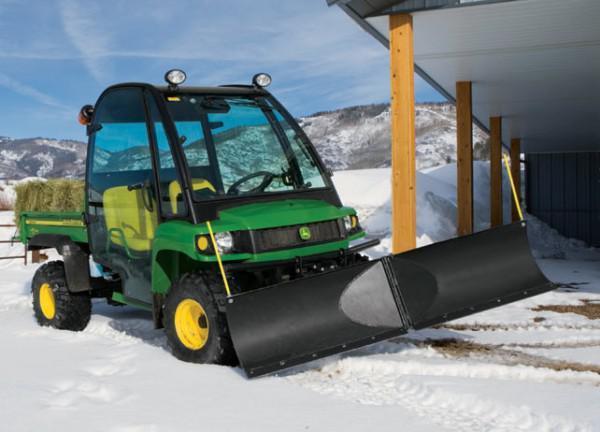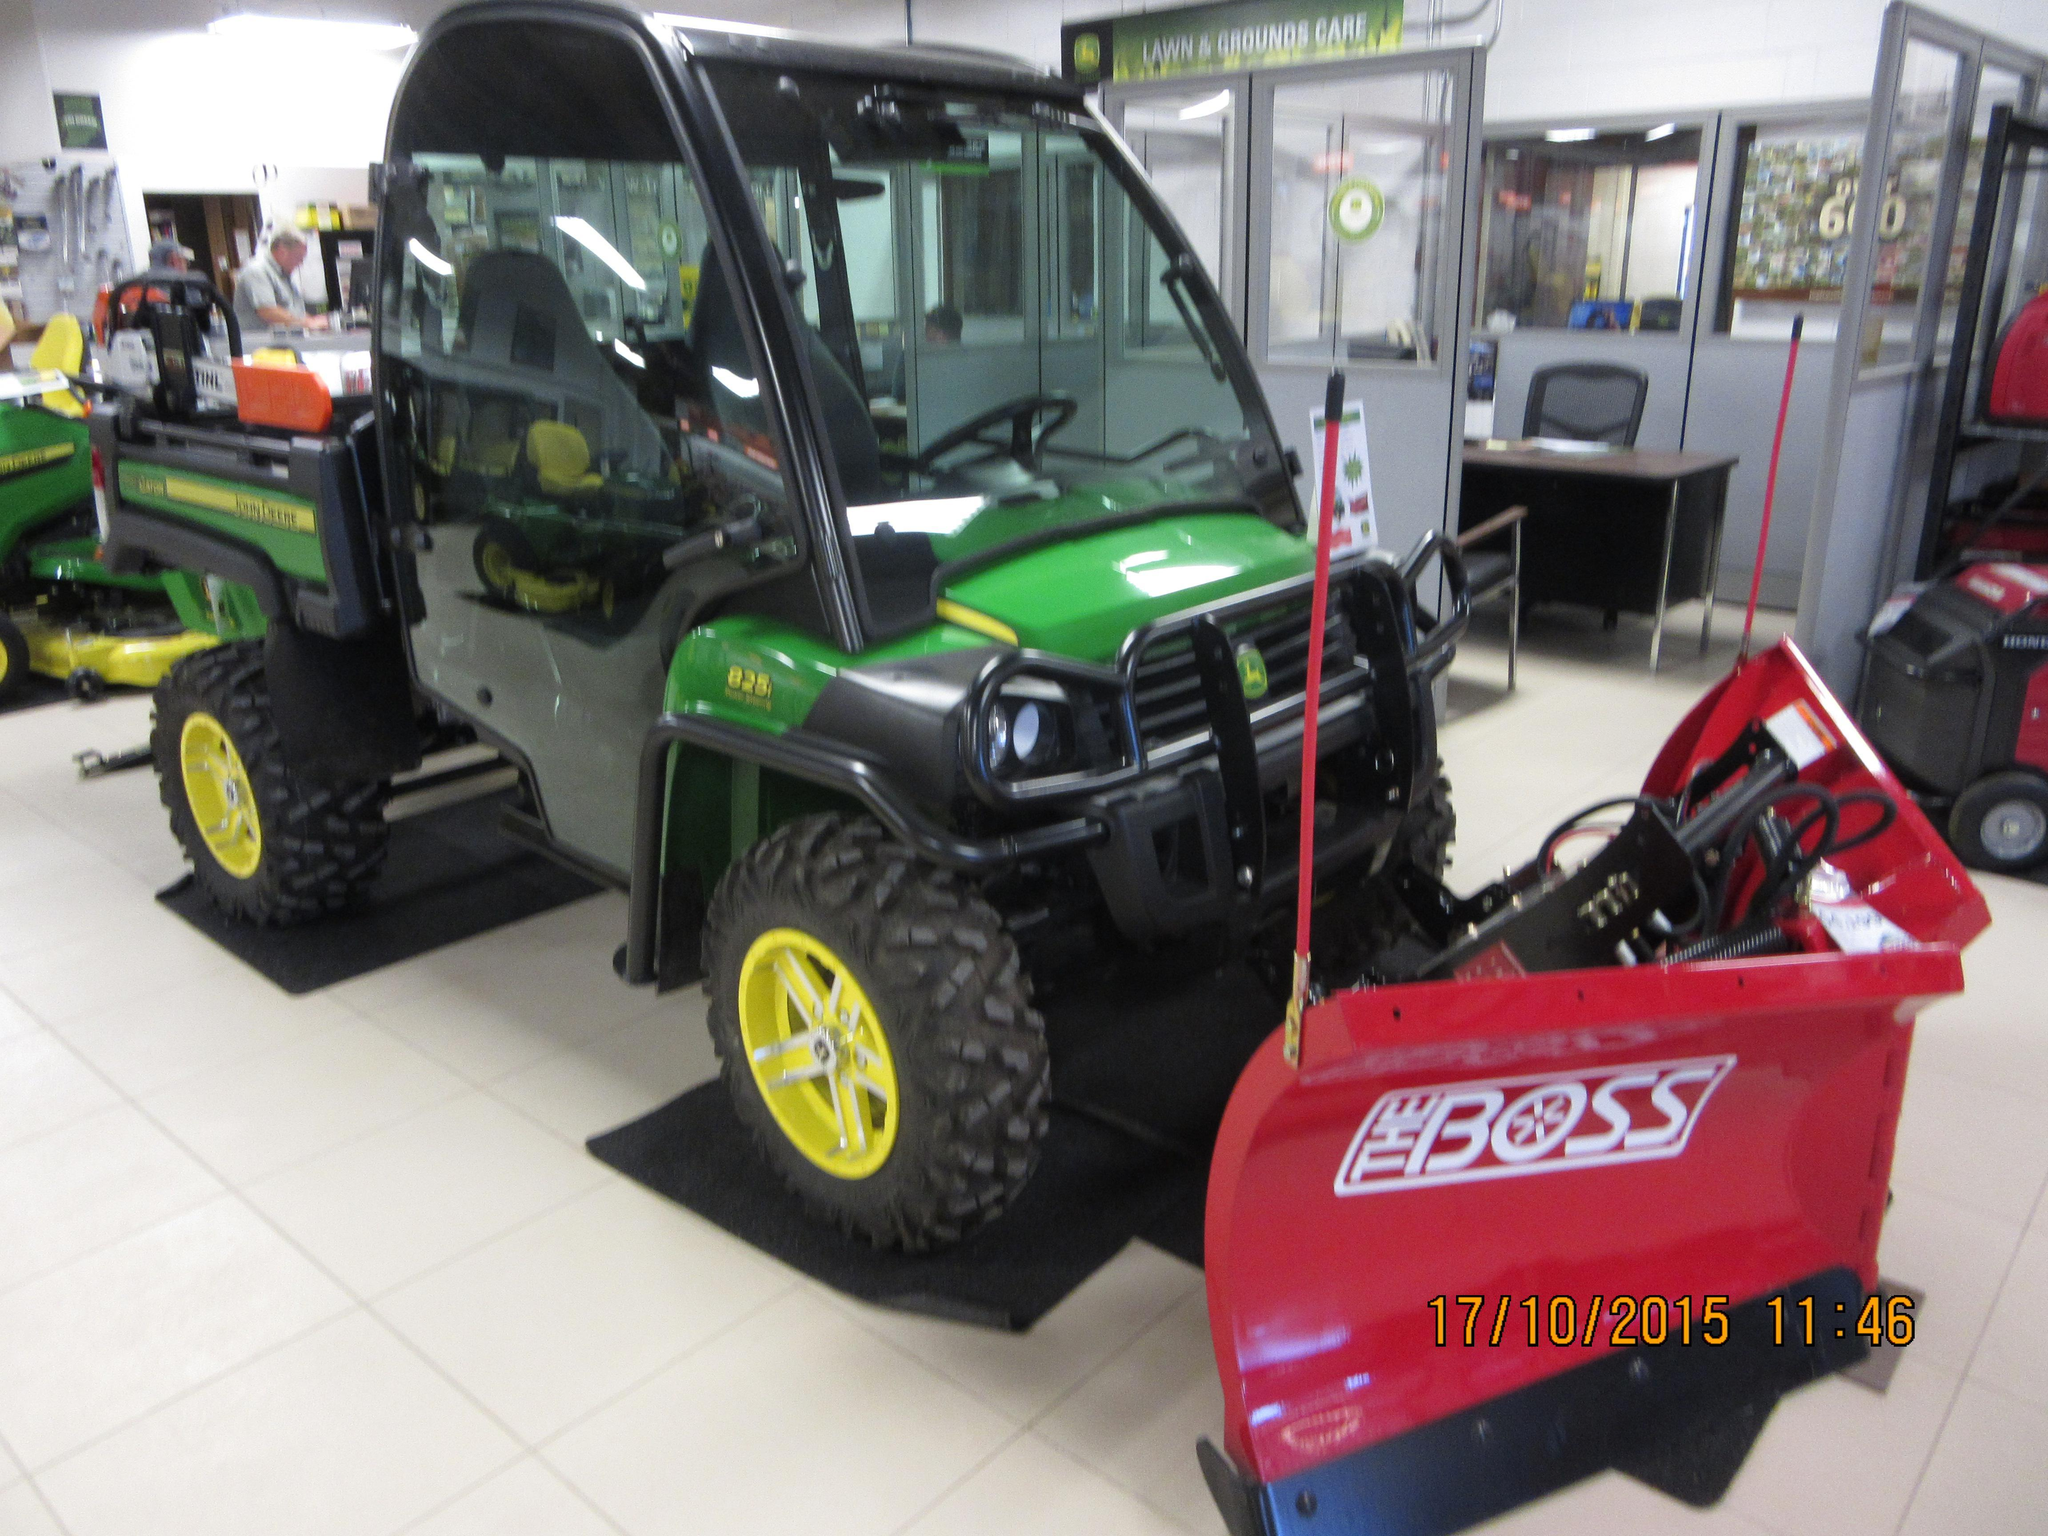The first image is the image on the left, the second image is the image on the right. Analyze the images presented: Is the assertion "One image features a vehicle with a red plow." valid? Answer yes or no. Yes. 